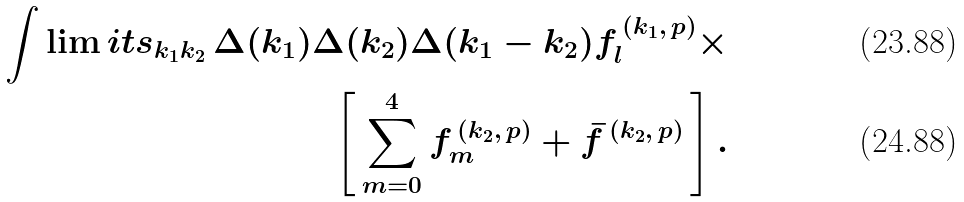Convert formula to latex. <formula><loc_0><loc_0><loc_500><loc_500>\int \lim i t s _ { k _ { 1 } k _ { 2 } } \, \Delta ( k _ { 1 } ) \Delta ( k _ { 2 } ) \Delta ( k _ { 1 } - k _ { 2 } ) f _ { l } ^ { \, ( k _ { 1 } , \, p ) } \times \\ \left [ \, \sum _ { m = 0 } ^ { 4 } f _ { m } ^ { \, ( k _ { 2 } , \, p ) } + { \bar { f } } ^ { \, ( k _ { 2 } , \, p ) } \, \right ] .</formula> 